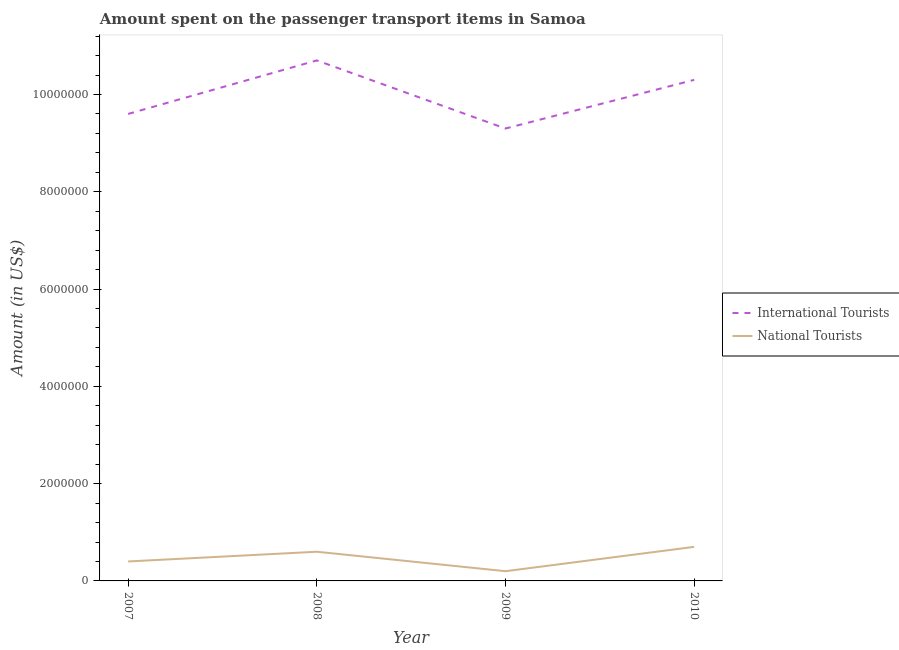How many different coloured lines are there?
Your response must be concise. 2. What is the amount spent on transport items of international tourists in 2009?
Offer a very short reply. 9.30e+06. In which year was the amount spent on transport items of national tourists maximum?
Offer a very short reply. 2010. In which year was the amount spent on transport items of international tourists minimum?
Ensure brevity in your answer.  2009. What is the total amount spent on transport items of international tourists in the graph?
Your answer should be compact. 3.99e+07. What is the difference between the amount spent on transport items of international tourists in 2007 and the amount spent on transport items of national tourists in 2010?
Your answer should be compact. 8.90e+06. What is the average amount spent on transport items of international tourists per year?
Make the answer very short. 9.98e+06. In the year 2007, what is the difference between the amount spent on transport items of national tourists and amount spent on transport items of international tourists?
Offer a terse response. -9.20e+06. What is the ratio of the amount spent on transport items of international tourists in 2008 to that in 2010?
Keep it short and to the point. 1.04. Is the difference between the amount spent on transport items of international tourists in 2008 and 2010 greater than the difference between the amount spent on transport items of national tourists in 2008 and 2010?
Keep it short and to the point. Yes. What is the difference between the highest and the lowest amount spent on transport items of international tourists?
Your response must be concise. 1.40e+06. In how many years, is the amount spent on transport items of international tourists greater than the average amount spent on transport items of international tourists taken over all years?
Your answer should be compact. 2. Is the sum of the amount spent on transport items of international tourists in 2008 and 2010 greater than the maximum amount spent on transport items of national tourists across all years?
Ensure brevity in your answer.  Yes. How many lines are there?
Provide a succinct answer. 2. How many years are there in the graph?
Offer a very short reply. 4. What is the difference between two consecutive major ticks on the Y-axis?
Ensure brevity in your answer.  2.00e+06. Are the values on the major ticks of Y-axis written in scientific E-notation?
Offer a terse response. No. Does the graph contain grids?
Offer a very short reply. No. Where does the legend appear in the graph?
Your answer should be very brief. Center right. How many legend labels are there?
Your answer should be very brief. 2. What is the title of the graph?
Your answer should be compact. Amount spent on the passenger transport items in Samoa. Does "Male" appear as one of the legend labels in the graph?
Offer a terse response. No. What is the label or title of the Y-axis?
Offer a very short reply. Amount (in US$). What is the Amount (in US$) of International Tourists in 2007?
Your answer should be very brief. 9.60e+06. What is the Amount (in US$) in International Tourists in 2008?
Offer a very short reply. 1.07e+07. What is the Amount (in US$) in International Tourists in 2009?
Ensure brevity in your answer.  9.30e+06. What is the Amount (in US$) of National Tourists in 2009?
Keep it short and to the point. 2.00e+05. What is the Amount (in US$) of International Tourists in 2010?
Offer a terse response. 1.03e+07. What is the Amount (in US$) in National Tourists in 2010?
Ensure brevity in your answer.  7.00e+05. Across all years, what is the maximum Amount (in US$) in International Tourists?
Provide a succinct answer. 1.07e+07. Across all years, what is the maximum Amount (in US$) in National Tourists?
Provide a short and direct response. 7.00e+05. Across all years, what is the minimum Amount (in US$) of International Tourists?
Provide a succinct answer. 9.30e+06. What is the total Amount (in US$) in International Tourists in the graph?
Give a very brief answer. 3.99e+07. What is the total Amount (in US$) of National Tourists in the graph?
Ensure brevity in your answer.  1.90e+06. What is the difference between the Amount (in US$) in International Tourists in 2007 and that in 2008?
Offer a very short reply. -1.10e+06. What is the difference between the Amount (in US$) of International Tourists in 2007 and that in 2009?
Offer a terse response. 3.00e+05. What is the difference between the Amount (in US$) of National Tourists in 2007 and that in 2009?
Your answer should be very brief. 2.00e+05. What is the difference between the Amount (in US$) of International Tourists in 2007 and that in 2010?
Ensure brevity in your answer.  -7.00e+05. What is the difference between the Amount (in US$) in International Tourists in 2008 and that in 2009?
Your response must be concise. 1.40e+06. What is the difference between the Amount (in US$) of National Tourists in 2008 and that in 2009?
Ensure brevity in your answer.  4.00e+05. What is the difference between the Amount (in US$) of International Tourists in 2009 and that in 2010?
Offer a very short reply. -1.00e+06. What is the difference between the Amount (in US$) of National Tourists in 2009 and that in 2010?
Provide a short and direct response. -5.00e+05. What is the difference between the Amount (in US$) in International Tourists in 2007 and the Amount (in US$) in National Tourists in 2008?
Offer a very short reply. 9.00e+06. What is the difference between the Amount (in US$) of International Tourists in 2007 and the Amount (in US$) of National Tourists in 2009?
Provide a short and direct response. 9.40e+06. What is the difference between the Amount (in US$) in International Tourists in 2007 and the Amount (in US$) in National Tourists in 2010?
Ensure brevity in your answer.  8.90e+06. What is the difference between the Amount (in US$) in International Tourists in 2008 and the Amount (in US$) in National Tourists in 2009?
Keep it short and to the point. 1.05e+07. What is the difference between the Amount (in US$) of International Tourists in 2008 and the Amount (in US$) of National Tourists in 2010?
Make the answer very short. 1.00e+07. What is the difference between the Amount (in US$) in International Tourists in 2009 and the Amount (in US$) in National Tourists in 2010?
Provide a short and direct response. 8.60e+06. What is the average Amount (in US$) in International Tourists per year?
Your answer should be compact. 9.98e+06. What is the average Amount (in US$) in National Tourists per year?
Provide a succinct answer. 4.75e+05. In the year 2007, what is the difference between the Amount (in US$) of International Tourists and Amount (in US$) of National Tourists?
Ensure brevity in your answer.  9.20e+06. In the year 2008, what is the difference between the Amount (in US$) of International Tourists and Amount (in US$) of National Tourists?
Provide a short and direct response. 1.01e+07. In the year 2009, what is the difference between the Amount (in US$) in International Tourists and Amount (in US$) in National Tourists?
Offer a very short reply. 9.10e+06. In the year 2010, what is the difference between the Amount (in US$) of International Tourists and Amount (in US$) of National Tourists?
Give a very brief answer. 9.60e+06. What is the ratio of the Amount (in US$) of International Tourists in 2007 to that in 2008?
Provide a short and direct response. 0.9. What is the ratio of the Amount (in US$) in National Tourists in 2007 to that in 2008?
Give a very brief answer. 0.67. What is the ratio of the Amount (in US$) of International Tourists in 2007 to that in 2009?
Offer a very short reply. 1.03. What is the ratio of the Amount (in US$) in National Tourists in 2007 to that in 2009?
Provide a succinct answer. 2. What is the ratio of the Amount (in US$) in International Tourists in 2007 to that in 2010?
Ensure brevity in your answer.  0.93. What is the ratio of the Amount (in US$) in International Tourists in 2008 to that in 2009?
Provide a short and direct response. 1.15. What is the ratio of the Amount (in US$) of National Tourists in 2008 to that in 2009?
Your answer should be very brief. 3. What is the ratio of the Amount (in US$) in International Tourists in 2008 to that in 2010?
Give a very brief answer. 1.04. What is the ratio of the Amount (in US$) in National Tourists in 2008 to that in 2010?
Your answer should be compact. 0.86. What is the ratio of the Amount (in US$) of International Tourists in 2009 to that in 2010?
Offer a terse response. 0.9. What is the ratio of the Amount (in US$) in National Tourists in 2009 to that in 2010?
Provide a short and direct response. 0.29. What is the difference between the highest and the lowest Amount (in US$) of International Tourists?
Your response must be concise. 1.40e+06. What is the difference between the highest and the lowest Amount (in US$) in National Tourists?
Keep it short and to the point. 5.00e+05. 